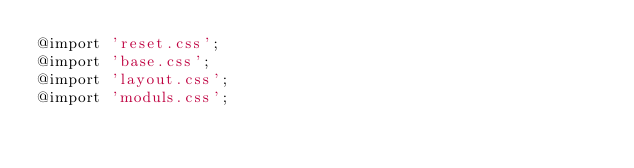Convert code to text. <code><loc_0><loc_0><loc_500><loc_500><_CSS_>@import 'reset.css';
@import 'base.css';
@import 'layout.css';
@import 'moduls.css';

</code> 